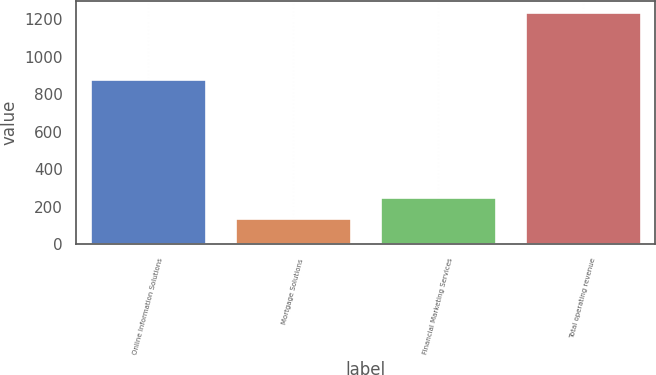<chart> <loc_0><loc_0><loc_500><loc_500><bar_chart><fcel>Online Information Solutions<fcel>Mortgage Solutions<fcel>Financial Marketing Services<fcel>Total operating revenue<nl><fcel>879.3<fcel>142.2<fcel>251.63<fcel>1236.5<nl></chart> 